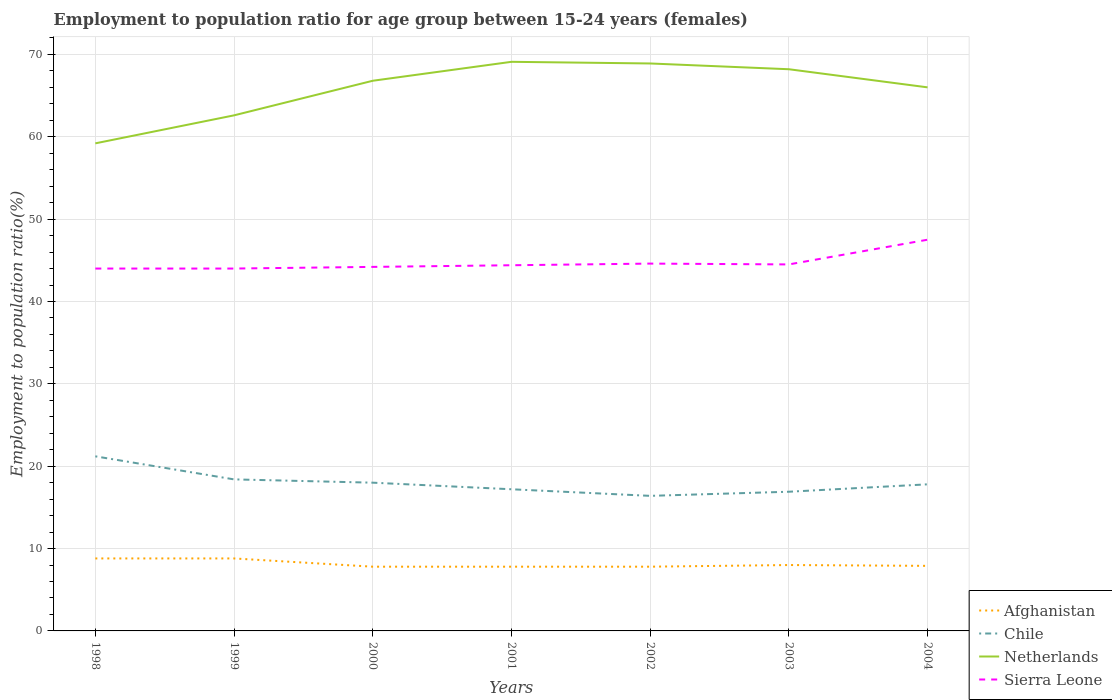Is the number of lines equal to the number of legend labels?
Offer a very short reply. Yes. Across all years, what is the maximum employment to population ratio in Netherlands?
Make the answer very short. 59.2. In which year was the employment to population ratio in Afghanistan maximum?
Offer a very short reply. 2000. What is the total employment to population ratio in Netherlands in the graph?
Make the answer very short. 0.2. What is the difference between the highest and the second highest employment to population ratio in Sierra Leone?
Offer a very short reply. 3.5. What is the difference between the highest and the lowest employment to population ratio in Chile?
Your answer should be very brief. 3. Is the employment to population ratio in Netherlands strictly greater than the employment to population ratio in Chile over the years?
Your answer should be very brief. No. How many years are there in the graph?
Offer a very short reply. 7. What is the difference between two consecutive major ticks on the Y-axis?
Offer a terse response. 10. Are the values on the major ticks of Y-axis written in scientific E-notation?
Offer a terse response. No. Where does the legend appear in the graph?
Provide a succinct answer. Bottom right. How many legend labels are there?
Provide a succinct answer. 4. What is the title of the graph?
Offer a terse response. Employment to population ratio for age group between 15-24 years (females). Does "Japan" appear as one of the legend labels in the graph?
Ensure brevity in your answer.  No. What is the label or title of the X-axis?
Make the answer very short. Years. What is the Employment to population ratio(%) of Afghanistan in 1998?
Your response must be concise. 8.8. What is the Employment to population ratio(%) in Chile in 1998?
Give a very brief answer. 21.2. What is the Employment to population ratio(%) of Netherlands in 1998?
Your answer should be very brief. 59.2. What is the Employment to population ratio(%) of Sierra Leone in 1998?
Make the answer very short. 44. What is the Employment to population ratio(%) in Afghanistan in 1999?
Your answer should be compact. 8.8. What is the Employment to population ratio(%) in Chile in 1999?
Ensure brevity in your answer.  18.4. What is the Employment to population ratio(%) in Netherlands in 1999?
Give a very brief answer. 62.6. What is the Employment to population ratio(%) of Afghanistan in 2000?
Keep it short and to the point. 7.8. What is the Employment to population ratio(%) of Chile in 2000?
Offer a very short reply. 18. What is the Employment to population ratio(%) of Netherlands in 2000?
Offer a terse response. 66.8. What is the Employment to population ratio(%) of Sierra Leone in 2000?
Ensure brevity in your answer.  44.2. What is the Employment to population ratio(%) in Afghanistan in 2001?
Give a very brief answer. 7.8. What is the Employment to population ratio(%) of Chile in 2001?
Your response must be concise. 17.2. What is the Employment to population ratio(%) of Netherlands in 2001?
Keep it short and to the point. 69.1. What is the Employment to population ratio(%) of Sierra Leone in 2001?
Make the answer very short. 44.4. What is the Employment to population ratio(%) in Afghanistan in 2002?
Provide a short and direct response. 7.8. What is the Employment to population ratio(%) of Chile in 2002?
Offer a terse response. 16.4. What is the Employment to population ratio(%) of Netherlands in 2002?
Provide a succinct answer. 68.9. What is the Employment to population ratio(%) in Sierra Leone in 2002?
Your answer should be compact. 44.6. What is the Employment to population ratio(%) of Afghanistan in 2003?
Keep it short and to the point. 8. What is the Employment to population ratio(%) in Chile in 2003?
Keep it short and to the point. 16.9. What is the Employment to population ratio(%) of Netherlands in 2003?
Ensure brevity in your answer.  68.2. What is the Employment to population ratio(%) of Sierra Leone in 2003?
Your answer should be compact. 44.5. What is the Employment to population ratio(%) of Afghanistan in 2004?
Provide a succinct answer. 7.9. What is the Employment to population ratio(%) in Chile in 2004?
Make the answer very short. 17.8. What is the Employment to population ratio(%) in Netherlands in 2004?
Ensure brevity in your answer.  66. What is the Employment to population ratio(%) in Sierra Leone in 2004?
Keep it short and to the point. 47.5. Across all years, what is the maximum Employment to population ratio(%) of Afghanistan?
Offer a very short reply. 8.8. Across all years, what is the maximum Employment to population ratio(%) in Chile?
Your response must be concise. 21.2. Across all years, what is the maximum Employment to population ratio(%) in Netherlands?
Your answer should be compact. 69.1. Across all years, what is the maximum Employment to population ratio(%) of Sierra Leone?
Offer a terse response. 47.5. Across all years, what is the minimum Employment to population ratio(%) of Afghanistan?
Offer a very short reply. 7.8. Across all years, what is the minimum Employment to population ratio(%) in Chile?
Keep it short and to the point. 16.4. Across all years, what is the minimum Employment to population ratio(%) of Netherlands?
Give a very brief answer. 59.2. What is the total Employment to population ratio(%) in Afghanistan in the graph?
Provide a short and direct response. 56.9. What is the total Employment to population ratio(%) in Chile in the graph?
Your answer should be compact. 125.9. What is the total Employment to population ratio(%) of Netherlands in the graph?
Keep it short and to the point. 460.8. What is the total Employment to population ratio(%) in Sierra Leone in the graph?
Offer a very short reply. 313.2. What is the difference between the Employment to population ratio(%) in Afghanistan in 1998 and that in 1999?
Give a very brief answer. 0. What is the difference between the Employment to population ratio(%) in Netherlands in 1998 and that in 1999?
Your response must be concise. -3.4. What is the difference between the Employment to population ratio(%) of Sierra Leone in 1998 and that in 1999?
Make the answer very short. 0. What is the difference between the Employment to population ratio(%) in Chile in 1998 and that in 2000?
Your answer should be very brief. 3.2. What is the difference between the Employment to population ratio(%) of Netherlands in 1998 and that in 2000?
Your answer should be compact. -7.6. What is the difference between the Employment to population ratio(%) of Sierra Leone in 1998 and that in 2000?
Make the answer very short. -0.2. What is the difference between the Employment to population ratio(%) of Afghanistan in 1998 and that in 2001?
Provide a short and direct response. 1. What is the difference between the Employment to population ratio(%) of Netherlands in 1998 and that in 2001?
Offer a very short reply. -9.9. What is the difference between the Employment to population ratio(%) of Afghanistan in 1998 and that in 2002?
Make the answer very short. 1. What is the difference between the Employment to population ratio(%) of Netherlands in 1998 and that in 2002?
Make the answer very short. -9.7. What is the difference between the Employment to population ratio(%) in Afghanistan in 1998 and that in 2003?
Your answer should be compact. 0.8. What is the difference between the Employment to population ratio(%) in Chile in 1998 and that in 2003?
Your answer should be very brief. 4.3. What is the difference between the Employment to population ratio(%) of Netherlands in 1998 and that in 2003?
Your answer should be compact. -9. What is the difference between the Employment to population ratio(%) of Sierra Leone in 1998 and that in 2003?
Offer a terse response. -0.5. What is the difference between the Employment to population ratio(%) of Afghanistan in 1999 and that in 2000?
Offer a very short reply. 1. What is the difference between the Employment to population ratio(%) of Chile in 1999 and that in 2000?
Your answer should be very brief. 0.4. What is the difference between the Employment to population ratio(%) of Sierra Leone in 1999 and that in 2000?
Your response must be concise. -0.2. What is the difference between the Employment to population ratio(%) of Chile in 1999 and that in 2001?
Make the answer very short. 1.2. What is the difference between the Employment to population ratio(%) of Sierra Leone in 1999 and that in 2001?
Keep it short and to the point. -0.4. What is the difference between the Employment to population ratio(%) of Chile in 1999 and that in 2003?
Offer a very short reply. 1.5. What is the difference between the Employment to population ratio(%) in Afghanistan in 1999 and that in 2004?
Give a very brief answer. 0.9. What is the difference between the Employment to population ratio(%) of Afghanistan in 2000 and that in 2001?
Keep it short and to the point. 0. What is the difference between the Employment to population ratio(%) in Netherlands in 2000 and that in 2001?
Your answer should be very brief. -2.3. What is the difference between the Employment to population ratio(%) in Sierra Leone in 2000 and that in 2001?
Provide a succinct answer. -0.2. What is the difference between the Employment to population ratio(%) in Afghanistan in 2000 and that in 2002?
Your answer should be compact. 0. What is the difference between the Employment to population ratio(%) of Afghanistan in 2000 and that in 2003?
Ensure brevity in your answer.  -0.2. What is the difference between the Employment to population ratio(%) in Chile in 2000 and that in 2003?
Ensure brevity in your answer.  1.1. What is the difference between the Employment to population ratio(%) of Netherlands in 2000 and that in 2003?
Your answer should be compact. -1.4. What is the difference between the Employment to population ratio(%) in Afghanistan in 2000 and that in 2004?
Ensure brevity in your answer.  -0.1. What is the difference between the Employment to population ratio(%) of Netherlands in 2000 and that in 2004?
Offer a very short reply. 0.8. What is the difference between the Employment to population ratio(%) in Sierra Leone in 2000 and that in 2004?
Your answer should be very brief. -3.3. What is the difference between the Employment to population ratio(%) of Afghanistan in 2001 and that in 2002?
Keep it short and to the point. 0. What is the difference between the Employment to population ratio(%) in Netherlands in 2001 and that in 2003?
Offer a terse response. 0.9. What is the difference between the Employment to population ratio(%) of Sierra Leone in 2001 and that in 2003?
Your answer should be compact. -0.1. What is the difference between the Employment to population ratio(%) in Chile in 2001 and that in 2004?
Keep it short and to the point. -0.6. What is the difference between the Employment to population ratio(%) of Sierra Leone in 2001 and that in 2004?
Provide a short and direct response. -3.1. What is the difference between the Employment to population ratio(%) in Afghanistan in 2002 and that in 2003?
Offer a terse response. -0.2. What is the difference between the Employment to population ratio(%) in Netherlands in 2002 and that in 2003?
Your answer should be very brief. 0.7. What is the difference between the Employment to population ratio(%) of Sierra Leone in 2002 and that in 2003?
Ensure brevity in your answer.  0.1. What is the difference between the Employment to population ratio(%) in Afghanistan in 2002 and that in 2004?
Your response must be concise. -0.1. What is the difference between the Employment to population ratio(%) of Chile in 2002 and that in 2004?
Offer a very short reply. -1.4. What is the difference between the Employment to population ratio(%) of Netherlands in 2002 and that in 2004?
Your answer should be very brief. 2.9. What is the difference between the Employment to population ratio(%) of Sierra Leone in 2002 and that in 2004?
Keep it short and to the point. -2.9. What is the difference between the Employment to population ratio(%) of Chile in 2003 and that in 2004?
Keep it short and to the point. -0.9. What is the difference between the Employment to population ratio(%) of Afghanistan in 1998 and the Employment to population ratio(%) of Netherlands in 1999?
Make the answer very short. -53.8. What is the difference between the Employment to population ratio(%) of Afghanistan in 1998 and the Employment to population ratio(%) of Sierra Leone in 1999?
Provide a short and direct response. -35.2. What is the difference between the Employment to population ratio(%) in Chile in 1998 and the Employment to population ratio(%) in Netherlands in 1999?
Offer a very short reply. -41.4. What is the difference between the Employment to population ratio(%) of Chile in 1998 and the Employment to population ratio(%) of Sierra Leone in 1999?
Make the answer very short. -22.8. What is the difference between the Employment to population ratio(%) in Afghanistan in 1998 and the Employment to population ratio(%) in Chile in 2000?
Your answer should be compact. -9.2. What is the difference between the Employment to population ratio(%) of Afghanistan in 1998 and the Employment to population ratio(%) of Netherlands in 2000?
Your response must be concise. -58. What is the difference between the Employment to population ratio(%) of Afghanistan in 1998 and the Employment to population ratio(%) of Sierra Leone in 2000?
Keep it short and to the point. -35.4. What is the difference between the Employment to population ratio(%) in Chile in 1998 and the Employment to population ratio(%) in Netherlands in 2000?
Your answer should be compact. -45.6. What is the difference between the Employment to population ratio(%) in Chile in 1998 and the Employment to population ratio(%) in Sierra Leone in 2000?
Provide a succinct answer. -23. What is the difference between the Employment to population ratio(%) in Afghanistan in 1998 and the Employment to population ratio(%) in Netherlands in 2001?
Your response must be concise. -60.3. What is the difference between the Employment to population ratio(%) of Afghanistan in 1998 and the Employment to population ratio(%) of Sierra Leone in 2001?
Your response must be concise. -35.6. What is the difference between the Employment to population ratio(%) in Chile in 1998 and the Employment to population ratio(%) in Netherlands in 2001?
Provide a short and direct response. -47.9. What is the difference between the Employment to population ratio(%) of Chile in 1998 and the Employment to population ratio(%) of Sierra Leone in 2001?
Your response must be concise. -23.2. What is the difference between the Employment to population ratio(%) in Afghanistan in 1998 and the Employment to population ratio(%) in Netherlands in 2002?
Provide a short and direct response. -60.1. What is the difference between the Employment to population ratio(%) in Afghanistan in 1998 and the Employment to population ratio(%) in Sierra Leone in 2002?
Your response must be concise. -35.8. What is the difference between the Employment to population ratio(%) of Chile in 1998 and the Employment to population ratio(%) of Netherlands in 2002?
Ensure brevity in your answer.  -47.7. What is the difference between the Employment to population ratio(%) in Chile in 1998 and the Employment to population ratio(%) in Sierra Leone in 2002?
Make the answer very short. -23.4. What is the difference between the Employment to population ratio(%) in Netherlands in 1998 and the Employment to population ratio(%) in Sierra Leone in 2002?
Ensure brevity in your answer.  14.6. What is the difference between the Employment to population ratio(%) in Afghanistan in 1998 and the Employment to population ratio(%) in Netherlands in 2003?
Your answer should be compact. -59.4. What is the difference between the Employment to population ratio(%) in Afghanistan in 1998 and the Employment to population ratio(%) in Sierra Leone in 2003?
Give a very brief answer. -35.7. What is the difference between the Employment to population ratio(%) in Chile in 1998 and the Employment to population ratio(%) in Netherlands in 2003?
Offer a very short reply. -47. What is the difference between the Employment to population ratio(%) of Chile in 1998 and the Employment to population ratio(%) of Sierra Leone in 2003?
Your answer should be compact. -23.3. What is the difference between the Employment to population ratio(%) in Afghanistan in 1998 and the Employment to population ratio(%) in Chile in 2004?
Provide a short and direct response. -9. What is the difference between the Employment to population ratio(%) in Afghanistan in 1998 and the Employment to population ratio(%) in Netherlands in 2004?
Your response must be concise. -57.2. What is the difference between the Employment to population ratio(%) in Afghanistan in 1998 and the Employment to population ratio(%) in Sierra Leone in 2004?
Ensure brevity in your answer.  -38.7. What is the difference between the Employment to population ratio(%) of Chile in 1998 and the Employment to population ratio(%) of Netherlands in 2004?
Offer a very short reply. -44.8. What is the difference between the Employment to population ratio(%) of Chile in 1998 and the Employment to population ratio(%) of Sierra Leone in 2004?
Make the answer very short. -26.3. What is the difference between the Employment to population ratio(%) in Netherlands in 1998 and the Employment to population ratio(%) in Sierra Leone in 2004?
Provide a short and direct response. 11.7. What is the difference between the Employment to population ratio(%) in Afghanistan in 1999 and the Employment to population ratio(%) in Chile in 2000?
Make the answer very short. -9.2. What is the difference between the Employment to population ratio(%) in Afghanistan in 1999 and the Employment to population ratio(%) in Netherlands in 2000?
Your response must be concise. -58. What is the difference between the Employment to population ratio(%) of Afghanistan in 1999 and the Employment to population ratio(%) of Sierra Leone in 2000?
Your response must be concise. -35.4. What is the difference between the Employment to population ratio(%) in Chile in 1999 and the Employment to population ratio(%) in Netherlands in 2000?
Ensure brevity in your answer.  -48.4. What is the difference between the Employment to population ratio(%) in Chile in 1999 and the Employment to population ratio(%) in Sierra Leone in 2000?
Provide a succinct answer. -25.8. What is the difference between the Employment to population ratio(%) of Afghanistan in 1999 and the Employment to population ratio(%) of Netherlands in 2001?
Provide a succinct answer. -60.3. What is the difference between the Employment to population ratio(%) in Afghanistan in 1999 and the Employment to population ratio(%) in Sierra Leone in 2001?
Provide a short and direct response. -35.6. What is the difference between the Employment to population ratio(%) in Chile in 1999 and the Employment to population ratio(%) in Netherlands in 2001?
Your answer should be compact. -50.7. What is the difference between the Employment to population ratio(%) in Netherlands in 1999 and the Employment to population ratio(%) in Sierra Leone in 2001?
Offer a very short reply. 18.2. What is the difference between the Employment to population ratio(%) of Afghanistan in 1999 and the Employment to population ratio(%) of Netherlands in 2002?
Offer a very short reply. -60.1. What is the difference between the Employment to population ratio(%) in Afghanistan in 1999 and the Employment to population ratio(%) in Sierra Leone in 2002?
Keep it short and to the point. -35.8. What is the difference between the Employment to population ratio(%) in Chile in 1999 and the Employment to population ratio(%) in Netherlands in 2002?
Provide a succinct answer. -50.5. What is the difference between the Employment to population ratio(%) of Chile in 1999 and the Employment to population ratio(%) of Sierra Leone in 2002?
Offer a terse response. -26.2. What is the difference between the Employment to population ratio(%) in Netherlands in 1999 and the Employment to population ratio(%) in Sierra Leone in 2002?
Offer a terse response. 18. What is the difference between the Employment to population ratio(%) of Afghanistan in 1999 and the Employment to population ratio(%) of Chile in 2003?
Make the answer very short. -8.1. What is the difference between the Employment to population ratio(%) in Afghanistan in 1999 and the Employment to population ratio(%) in Netherlands in 2003?
Give a very brief answer. -59.4. What is the difference between the Employment to population ratio(%) of Afghanistan in 1999 and the Employment to population ratio(%) of Sierra Leone in 2003?
Offer a terse response. -35.7. What is the difference between the Employment to population ratio(%) in Chile in 1999 and the Employment to population ratio(%) in Netherlands in 2003?
Provide a succinct answer. -49.8. What is the difference between the Employment to population ratio(%) of Chile in 1999 and the Employment to population ratio(%) of Sierra Leone in 2003?
Offer a very short reply. -26.1. What is the difference between the Employment to population ratio(%) in Netherlands in 1999 and the Employment to population ratio(%) in Sierra Leone in 2003?
Your answer should be compact. 18.1. What is the difference between the Employment to population ratio(%) in Afghanistan in 1999 and the Employment to population ratio(%) in Chile in 2004?
Provide a short and direct response. -9. What is the difference between the Employment to population ratio(%) in Afghanistan in 1999 and the Employment to population ratio(%) in Netherlands in 2004?
Provide a short and direct response. -57.2. What is the difference between the Employment to population ratio(%) in Afghanistan in 1999 and the Employment to population ratio(%) in Sierra Leone in 2004?
Give a very brief answer. -38.7. What is the difference between the Employment to population ratio(%) in Chile in 1999 and the Employment to population ratio(%) in Netherlands in 2004?
Your answer should be compact. -47.6. What is the difference between the Employment to population ratio(%) of Chile in 1999 and the Employment to population ratio(%) of Sierra Leone in 2004?
Provide a succinct answer. -29.1. What is the difference between the Employment to population ratio(%) in Afghanistan in 2000 and the Employment to population ratio(%) in Netherlands in 2001?
Give a very brief answer. -61.3. What is the difference between the Employment to population ratio(%) of Afghanistan in 2000 and the Employment to population ratio(%) of Sierra Leone in 2001?
Provide a short and direct response. -36.6. What is the difference between the Employment to population ratio(%) of Chile in 2000 and the Employment to population ratio(%) of Netherlands in 2001?
Provide a succinct answer. -51.1. What is the difference between the Employment to population ratio(%) of Chile in 2000 and the Employment to population ratio(%) of Sierra Leone in 2001?
Your answer should be very brief. -26.4. What is the difference between the Employment to population ratio(%) of Netherlands in 2000 and the Employment to population ratio(%) of Sierra Leone in 2001?
Your answer should be very brief. 22.4. What is the difference between the Employment to population ratio(%) of Afghanistan in 2000 and the Employment to population ratio(%) of Chile in 2002?
Make the answer very short. -8.6. What is the difference between the Employment to population ratio(%) of Afghanistan in 2000 and the Employment to population ratio(%) of Netherlands in 2002?
Keep it short and to the point. -61.1. What is the difference between the Employment to population ratio(%) in Afghanistan in 2000 and the Employment to population ratio(%) in Sierra Leone in 2002?
Offer a very short reply. -36.8. What is the difference between the Employment to population ratio(%) in Chile in 2000 and the Employment to population ratio(%) in Netherlands in 2002?
Ensure brevity in your answer.  -50.9. What is the difference between the Employment to population ratio(%) of Chile in 2000 and the Employment to population ratio(%) of Sierra Leone in 2002?
Your response must be concise. -26.6. What is the difference between the Employment to population ratio(%) in Netherlands in 2000 and the Employment to population ratio(%) in Sierra Leone in 2002?
Make the answer very short. 22.2. What is the difference between the Employment to population ratio(%) of Afghanistan in 2000 and the Employment to population ratio(%) of Chile in 2003?
Your answer should be very brief. -9.1. What is the difference between the Employment to population ratio(%) in Afghanistan in 2000 and the Employment to population ratio(%) in Netherlands in 2003?
Offer a terse response. -60.4. What is the difference between the Employment to population ratio(%) of Afghanistan in 2000 and the Employment to population ratio(%) of Sierra Leone in 2003?
Give a very brief answer. -36.7. What is the difference between the Employment to population ratio(%) of Chile in 2000 and the Employment to population ratio(%) of Netherlands in 2003?
Provide a succinct answer. -50.2. What is the difference between the Employment to population ratio(%) of Chile in 2000 and the Employment to population ratio(%) of Sierra Leone in 2003?
Offer a terse response. -26.5. What is the difference between the Employment to population ratio(%) in Netherlands in 2000 and the Employment to population ratio(%) in Sierra Leone in 2003?
Your answer should be compact. 22.3. What is the difference between the Employment to population ratio(%) in Afghanistan in 2000 and the Employment to population ratio(%) in Chile in 2004?
Make the answer very short. -10. What is the difference between the Employment to population ratio(%) of Afghanistan in 2000 and the Employment to population ratio(%) of Netherlands in 2004?
Provide a short and direct response. -58.2. What is the difference between the Employment to population ratio(%) in Afghanistan in 2000 and the Employment to population ratio(%) in Sierra Leone in 2004?
Make the answer very short. -39.7. What is the difference between the Employment to population ratio(%) in Chile in 2000 and the Employment to population ratio(%) in Netherlands in 2004?
Your answer should be compact. -48. What is the difference between the Employment to population ratio(%) in Chile in 2000 and the Employment to population ratio(%) in Sierra Leone in 2004?
Ensure brevity in your answer.  -29.5. What is the difference between the Employment to population ratio(%) in Netherlands in 2000 and the Employment to population ratio(%) in Sierra Leone in 2004?
Make the answer very short. 19.3. What is the difference between the Employment to population ratio(%) of Afghanistan in 2001 and the Employment to population ratio(%) of Netherlands in 2002?
Ensure brevity in your answer.  -61.1. What is the difference between the Employment to population ratio(%) in Afghanistan in 2001 and the Employment to population ratio(%) in Sierra Leone in 2002?
Ensure brevity in your answer.  -36.8. What is the difference between the Employment to population ratio(%) in Chile in 2001 and the Employment to population ratio(%) in Netherlands in 2002?
Provide a short and direct response. -51.7. What is the difference between the Employment to population ratio(%) in Chile in 2001 and the Employment to population ratio(%) in Sierra Leone in 2002?
Provide a short and direct response. -27.4. What is the difference between the Employment to population ratio(%) in Afghanistan in 2001 and the Employment to population ratio(%) in Netherlands in 2003?
Ensure brevity in your answer.  -60.4. What is the difference between the Employment to population ratio(%) of Afghanistan in 2001 and the Employment to population ratio(%) of Sierra Leone in 2003?
Make the answer very short. -36.7. What is the difference between the Employment to population ratio(%) in Chile in 2001 and the Employment to population ratio(%) in Netherlands in 2003?
Your answer should be very brief. -51. What is the difference between the Employment to population ratio(%) of Chile in 2001 and the Employment to population ratio(%) of Sierra Leone in 2003?
Ensure brevity in your answer.  -27.3. What is the difference between the Employment to population ratio(%) of Netherlands in 2001 and the Employment to population ratio(%) of Sierra Leone in 2003?
Keep it short and to the point. 24.6. What is the difference between the Employment to population ratio(%) of Afghanistan in 2001 and the Employment to population ratio(%) of Chile in 2004?
Your answer should be very brief. -10. What is the difference between the Employment to population ratio(%) of Afghanistan in 2001 and the Employment to population ratio(%) of Netherlands in 2004?
Offer a terse response. -58.2. What is the difference between the Employment to population ratio(%) in Afghanistan in 2001 and the Employment to population ratio(%) in Sierra Leone in 2004?
Keep it short and to the point. -39.7. What is the difference between the Employment to population ratio(%) of Chile in 2001 and the Employment to population ratio(%) of Netherlands in 2004?
Offer a very short reply. -48.8. What is the difference between the Employment to population ratio(%) in Chile in 2001 and the Employment to population ratio(%) in Sierra Leone in 2004?
Provide a succinct answer. -30.3. What is the difference between the Employment to population ratio(%) of Netherlands in 2001 and the Employment to population ratio(%) of Sierra Leone in 2004?
Offer a terse response. 21.6. What is the difference between the Employment to population ratio(%) of Afghanistan in 2002 and the Employment to population ratio(%) of Netherlands in 2003?
Provide a succinct answer. -60.4. What is the difference between the Employment to population ratio(%) of Afghanistan in 2002 and the Employment to population ratio(%) of Sierra Leone in 2003?
Offer a very short reply. -36.7. What is the difference between the Employment to population ratio(%) of Chile in 2002 and the Employment to population ratio(%) of Netherlands in 2003?
Offer a very short reply. -51.8. What is the difference between the Employment to population ratio(%) of Chile in 2002 and the Employment to population ratio(%) of Sierra Leone in 2003?
Make the answer very short. -28.1. What is the difference between the Employment to population ratio(%) of Netherlands in 2002 and the Employment to population ratio(%) of Sierra Leone in 2003?
Your response must be concise. 24.4. What is the difference between the Employment to population ratio(%) in Afghanistan in 2002 and the Employment to population ratio(%) in Chile in 2004?
Keep it short and to the point. -10. What is the difference between the Employment to population ratio(%) of Afghanistan in 2002 and the Employment to population ratio(%) of Netherlands in 2004?
Offer a very short reply. -58.2. What is the difference between the Employment to population ratio(%) of Afghanistan in 2002 and the Employment to population ratio(%) of Sierra Leone in 2004?
Provide a succinct answer. -39.7. What is the difference between the Employment to population ratio(%) in Chile in 2002 and the Employment to population ratio(%) in Netherlands in 2004?
Provide a short and direct response. -49.6. What is the difference between the Employment to population ratio(%) of Chile in 2002 and the Employment to population ratio(%) of Sierra Leone in 2004?
Your answer should be very brief. -31.1. What is the difference between the Employment to population ratio(%) in Netherlands in 2002 and the Employment to population ratio(%) in Sierra Leone in 2004?
Offer a terse response. 21.4. What is the difference between the Employment to population ratio(%) of Afghanistan in 2003 and the Employment to population ratio(%) of Chile in 2004?
Offer a very short reply. -9.8. What is the difference between the Employment to population ratio(%) in Afghanistan in 2003 and the Employment to population ratio(%) in Netherlands in 2004?
Your answer should be compact. -58. What is the difference between the Employment to population ratio(%) of Afghanistan in 2003 and the Employment to population ratio(%) of Sierra Leone in 2004?
Keep it short and to the point. -39.5. What is the difference between the Employment to population ratio(%) of Chile in 2003 and the Employment to population ratio(%) of Netherlands in 2004?
Make the answer very short. -49.1. What is the difference between the Employment to population ratio(%) of Chile in 2003 and the Employment to population ratio(%) of Sierra Leone in 2004?
Your answer should be very brief. -30.6. What is the difference between the Employment to population ratio(%) of Netherlands in 2003 and the Employment to population ratio(%) of Sierra Leone in 2004?
Your answer should be very brief. 20.7. What is the average Employment to population ratio(%) in Afghanistan per year?
Your answer should be compact. 8.13. What is the average Employment to population ratio(%) of Chile per year?
Provide a succinct answer. 17.99. What is the average Employment to population ratio(%) in Netherlands per year?
Make the answer very short. 65.83. What is the average Employment to population ratio(%) in Sierra Leone per year?
Offer a very short reply. 44.74. In the year 1998, what is the difference between the Employment to population ratio(%) in Afghanistan and Employment to population ratio(%) in Netherlands?
Your answer should be very brief. -50.4. In the year 1998, what is the difference between the Employment to population ratio(%) of Afghanistan and Employment to population ratio(%) of Sierra Leone?
Your answer should be very brief. -35.2. In the year 1998, what is the difference between the Employment to population ratio(%) of Chile and Employment to population ratio(%) of Netherlands?
Make the answer very short. -38. In the year 1998, what is the difference between the Employment to population ratio(%) of Chile and Employment to population ratio(%) of Sierra Leone?
Your answer should be very brief. -22.8. In the year 1998, what is the difference between the Employment to population ratio(%) in Netherlands and Employment to population ratio(%) in Sierra Leone?
Your answer should be compact. 15.2. In the year 1999, what is the difference between the Employment to population ratio(%) in Afghanistan and Employment to population ratio(%) in Netherlands?
Offer a very short reply. -53.8. In the year 1999, what is the difference between the Employment to population ratio(%) of Afghanistan and Employment to population ratio(%) of Sierra Leone?
Your response must be concise. -35.2. In the year 1999, what is the difference between the Employment to population ratio(%) in Chile and Employment to population ratio(%) in Netherlands?
Give a very brief answer. -44.2. In the year 1999, what is the difference between the Employment to population ratio(%) of Chile and Employment to population ratio(%) of Sierra Leone?
Offer a terse response. -25.6. In the year 2000, what is the difference between the Employment to population ratio(%) of Afghanistan and Employment to population ratio(%) of Netherlands?
Make the answer very short. -59. In the year 2000, what is the difference between the Employment to population ratio(%) in Afghanistan and Employment to population ratio(%) in Sierra Leone?
Your response must be concise. -36.4. In the year 2000, what is the difference between the Employment to population ratio(%) of Chile and Employment to population ratio(%) of Netherlands?
Provide a short and direct response. -48.8. In the year 2000, what is the difference between the Employment to population ratio(%) in Chile and Employment to population ratio(%) in Sierra Leone?
Your answer should be compact. -26.2. In the year 2000, what is the difference between the Employment to population ratio(%) of Netherlands and Employment to population ratio(%) of Sierra Leone?
Your response must be concise. 22.6. In the year 2001, what is the difference between the Employment to population ratio(%) of Afghanistan and Employment to population ratio(%) of Chile?
Your answer should be very brief. -9.4. In the year 2001, what is the difference between the Employment to population ratio(%) in Afghanistan and Employment to population ratio(%) in Netherlands?
Ensure brevity in your answer.  -61.3. In the year 2001, what is the difference between the Employment to population ratio(%) of Afghanistan and Employment to population ratio(%) of Sierra Leone?
Your answer should be compact. -36.6. In the year 2001, what is the difference between the Employment to population ratio(%) of Chile and Employment to population ratio(%) of Netherlands?
Make the answer very short. -51.9. In the year 2001, what is the difference between the Employment to population ratio(%) of Chile and Employment to population ratio(%) of Sierra Leone?
Your answer should be compact. -27.2. In the year 2001, what is the difference between the Employment to population ratio(%) in Netherlands and Employment to population ratio(%) in Sierra Leone?
Offer a very short reply. 24.7. In the year 2002, what is the difference between the Employment to population ratio(%) of Afghanistan and Employment to population ratio(%) of Netherlands?
Your answer should be compact. -61.1. In the year 2002, what is the difference between the Employment to population ratio(%) in Afghanistan and Employment to population ratio(%) in Sierra Leone?
Provide a succinct answer. -36.8. In the year 2002, what is the difference between the Employment to population ratio(%) of Chile and Employment to population ratio(%) of Netherlands?
Your answer should be compact. -52.5. In the year 2002, what is the difference between the Employment to population ratio(%) of Chile and Employment to population ratio(%) of Sierra Leone?
Your answer should be very brief. -28.2. In the year 2002, what is the difference between the Employment to population ratio(%) of Netherlands and Employment to population ratio(%) of Sierra Leone?
Offer a terse response. 24.3. In the year 2003, what is the difference between the Employment to population ratio(%) in Afghanistan and Employment to population ratio(%) in Netherlands?
Offer a very short reply. -60.2. In the year 2003, what is the difference between the Employment to population ratio(%) of Afghanistan and Employment to population ratio(%) of Sierra Leone?
Provide a succinct answer. -36.5. In the year 2003, what is the difference between the Employment to population ratio(%) of Chile and Employment to population ratio(%) of Netherlands?
Give a very brief answer. -51.3. In the year 2003, what is the difference between the Employment to population ratio(%) in Chile and Employment to population ratio(%) in Sierra Leone?
Give a very brief answer. -27.6. In the year 2003, what is the difference between the Employment to population ratio(%) in Netherlands and Employment to population ratio(%) in Sierra Leone?
Keep it short and to the point. 23.7. In the year 2004, what is the difference between the Employment to population ratio(%) in Afghanistan and Employment to population ratio(%) in Netherlands?
Offer a very short reply. -58.1. In the year 2004, what is the difference between the Employment to population ratio(%) of Afghanistan and Employment to population ratio(%) of Sierra Leone?
Offer a terse response. -39.6. In the year 2004, what is the difference between the Employment to population ratio(%) of Chile and Employment to population ratio(%) of Netherlands?
Your answer should be very brief. -48.2. In the year 2004, what is the difference between the Employment to population ratio(%) in Chile and Employment to population ratio(%) in Sierra Leone?
Your response must be concise. -29.7. What is the ratio of the Employment to population ratio(%) in Afghanistan in 1998 to that in 1999?
Give a very brief answer. 1. What is the ratio of the Employment to population ratio(%) in Chile in 1998 to that in 1999?
Provide a succinct answer. 1.15. What is the ratio of the Employment to population ratio(%) in Netherlands in 1998 to that in 1999?
Your answer should be very brief. 0.95. What is the ratio of the Employment to population ratio(%) of Sierra Leone in 1998 to that in 1999?
Your answer should be compact. 1. What is the ratio of the Employment to population ratio(%) in Afghanistan in 1998 to that in 2000?
Provide a short and direct response. 1.13. What is the ratio of the Employment to population ratio(%) in Chile in 1998 to that in 2000?
Make the answer very short. 1.18. What is the ratio of the Employment to population ratio(%) in Netherlands in 1998 to that in 2000?
Provide a short and direct response. 0.89. What is the ratio of the Employment to population ratio(%) of Sierra Leone in 1998 to that in 2000?
Provide a short and direct response. 1. What is the ratio of the Employment to population ratio(%) in Afghanistan in 1998 to that in 2001?
Your answer should be very brief. 1.13. What is the ratio of the Employment to population ratio(%) of Chile in 1998 to that in 2001?
Provide a succinct answer. 1.23. What is the ratio of the Employment to population ratio(%) of Netherlands in 1998 to that in 2001?
Give a very brief answer. 0.86. What is the ratio of the Employment to population ratio(%) in Afghanistan in 1998 to that in 2002?
Your answer should be compact. 1.13. What is the ratio of the Employment to population ratio(%) in Chile in 1998 to that in 2002?
Ensure brevity in your answer.  1.29. What is the ratio of the Employment to population ratio(%) in Netherlands in 1998 to that in 2002?
Provide a succinct answer. 0.86. What is the ratio of the Employment to population ratio(%) of Sierra Leone in 1998 to that in 2002?
Your answer should be compact. 0.99. What is the ratio of the Employment to population ratio(%) in Chile in 1998 to that in 2003?
Keep it short and to the point. 1.25. What is the ratio of the Employment to population ratio(%) in Netherlands in 1998 to that in 2003?
Keep it short and to the point. 0.87. What is the ratio of the Employment to population ratio(%) in Afghanistan in 1998 to that in 2004?
Offer a terse response. 1.11. What is the ratio of the Employment to population ratio(%) in Chile in 1998 to that in 2004?
Ensure brevity in your answer.  1.19. What is the ratio of the Employment to population ratio(%) of Netherlands in 1998 to that in 2004?
Your response must be concise. 0.9. What is the ratio of the Employment to population ratio(%) in Sierra Leone in 1998 to that in 2004?
Offer a terse response. 0.93. What is the ratio of the Employment to population ratio(%) in Afghanistan in 1999 to that in 2000?
Provide a succinct answer. 1.13. What is the ratio of the Employment to population ratio(%) in Chile in 1999 to that in 2000?
Ensure brevity in your answer.  1.02. What is the ratio of the Employment to population ratio(%) of Netherlands in 1999 to that in 2000?
Keep it short and to the point. 0.94. What is the ratio of the Employment to population ratio(%) of Sierra Leone in 1999 to that in 2000?
Your answer should be very brief. 1. What is the ratio of the Employment to population ratio(%) in Afghanistan in 1999 to that in 2001?
Your response must be concise. 1.13. What is the ratio of the Employment to population ratio(%) in Chile in 1999 to that in 2001?
Your response must be concise. 1.07. What is the ratio of the Employment to population ratio(%) in Netherlands in 1999 to that in 2001?
Provide a short and direct response. 0.91. What is the ratio of the Employment to population ratio(%) in Afghanistan in 1999 to that in 2002?
Your answer should be very brief. 1.13. What is the ratio of the Employment to population ratio(%) in Chile in 1999 to that in 2002?
Give a very brief answer. 1.12. What is the ratio of the Employment to population ratio(%) in Netherlands in 1999 to that in 2002?
Provide a succinct answer. 0.91. What is the ratio of the Employment to population ratio(%) in Sierra Leone in 1999 to that in 2002?
Provide a succinct answer. 0.99. What is the ratio of the Employment to population ratio(%) in Afghanistan in 1999 to that in 2003?
Provide a succinct answer. 1.1. What is the ratio of the Employment to population ratio(%) in Chile in 1999 to that in 2003?
Keep it short and to the point. 1.09. What is the ratio of the Employment to population ratio(%) of Netherlands in 1999 to that in 2003?
Make the answer very short. 0.92. What is the ratio of the Employment to population ratio(%) of Afghanistan in 1999 to that in 2004?
Ensure brevity in your answer.  1.11. What is the ratio of the Employment to population ratio(%) in Chile in 1999 to that in 2004?
Offer a terse response. 1.03. What is the ratio of the Employment to population ratio(%) in Netherlands in 1999 to that in 2004?
Your answer should be compact. 0.95. What is the ratio of the Employment to population ratio(%) in Sierra Leone in 1999 to that in 2004?
Your answer should be very brief. 0.93. What is the ratio of the Employment to population ratio(%) in Chile in 2000 to that in 2001?
Make the answer very short. 1.05. What is the ratio of the Employment to population ratio(%) in Netherlands in 2000 to that in 2001?
Ensure brevity in your answer.  0.97. What is the ratio of the Employment to population ratio(%) of Chile in 2000 to that in 2002?
Ensure brevity in your answer.  1.1. What is the ratio of the Employment to population ratio(%) of Netherlands in 2000 to that in 2002?
Ensure brevity in your answer.  0.97. What is the ratio of the Employment to population ratio(%) of Afghanistan in 2000 to that in 2003?
Your response must be concise. 0.97. What is the ratio of the Employment to population ratio(%) of Chile in 2000 to that in 2003?
Make the answer very short. 1.07. What is the ratio of the Employment to population ratio(%) in Netherlands in 2000 to that in 2003?
Make the answer very short. 0.98. What is the ratio of the Employment to population ratio(%) of Sierra Leone in 2000 to that in 2003?
Give a very brief answer. 0.99. What is the ratio of the Employment to population ratio(%) of Afghanistan in 2000 to that in 2004?
Provide a succinct answer. 0.99. What is the ratio of the Employment to population ratio(%) of Chile in 2000 to that in 2004?
Your response must be concise. 1.01. What is the ratio of the Employment to population ratio(%) in Netherlands in 2000 to that in 2004?
Ensure brevity in your answer.  1.01. What is the ratio of the Employment to population ratio(%) in Sierra Leone in 2000 to that in 2004?
Your answer should be compact. 0.93. What is the ratio of the Employment to population ratio(%) in Chile in 2001 to that in 2002?
Provide a succinct answer. 1.05. What is the ratio of the Employment to population ratio(%) of Netherlands in 2001 to that in 2002?
Ensure brevity in your answer.  1. What is the ratio of the Employment to population ratio(%) of Afghanistan in 2001 to that in 2003?
Provide a short and direct response. 0.97. What is the ratio of the Employment to population ratio(%) in Chile in 2001 to that in 2003?
Ensure brevity in your answer.  1.02. What is the ratio of the Employment to population ratio(%) in Netherlands in 2001 to that in 2003?
Ensure brevity in your answer.  1.01. What is the ratio of the Employment to population ratio(%) in Afghanistan in 2001 to that in 2004?
Keep it short and to the point. 0.99. What is the ratio of the Employment to population ratio(%) of Chile in 2001 to that in 2004?
Provide a short and direct response. 0.97. What is the ratio of the Employment to population ratio(%) in Netherlands in 2001 to that in 2004?
Offer a terse response. 1.05. What is the ratio of the Employment to population ratio(%) in Sierra Leone in 2001 to that in 2004?
Keep it short and to the point. 0.93. What is the ratio of the Employment to population ratio(%) of Afghanistan in 2002 to that in 2003?
Provide a succinct answer. 0.97. What is the ratio of the Employment to population ratio(%) in Chile in 2002 to that in 2003?
Your answer should be very brief. 0.97. What is the ratio of the Employment to population ratio(%) of Netherlands in 2002 to that in 2003?
Give a very brief answer. 1.01. What is the ratio of the Employment to population ratio(%) of Sierra Leone in 2002 to that in 2003?
Offer a terse response. 1. What is the ratio of the Employment to population ratio(%) in Afghanistan in 2002 to that in 2004?
Make the answer very short. 0.99. What is the ratio of the Employment to population ratio(%) in Chile in 2002 to that in 2004?
Your answer should be very brief. 0.92. What is the ratio of the Employment to population ratio(%) of Netherlands in 2002 to that in 2004?
Provide a short and direct response. 1.04. What is the ratio of the Employment to population ratio(%) in Sierra Leone in 2002 to that in 2004?
Provide a short and direct response. 0.94. What is the ratio of the Employment to population ratio(%) in Afghanistan in 2003 to that in 2004?
Your response must be concise. 1.01. What is the ratio of the Employment to population ratio(%) of Chile in 2003 to that in 2004?
Your answer should be very brief. 0.95. What is the ratio of the Employment to population ratio(%) in Netherlands in 2003 to that in 2004?
Give a very brief answer. 1.03. What is the ratio of the Employment to population ratio(%) of Sierra Leone in 2003 to that in 2004?
Ensure brevity in your answer.  0.94. What is the difference between the highest and the lowest Employment to population ratio(%) in Afghanistan?
Give a very brief answer. 1. What is the difference between the highest and the lowest Employment to population ratio(%) of Netherlands?
Make the answer very short. 9.9. 